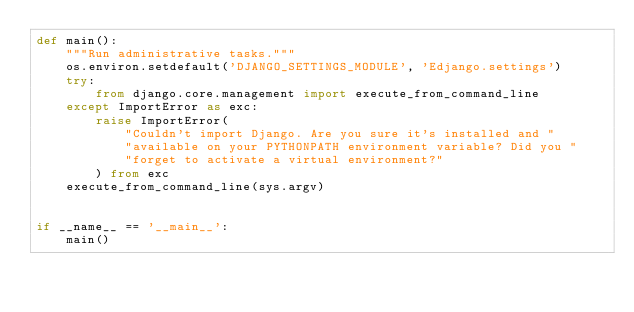<code> <loc_0><loc_0><loc_500><loc_500><_Python_>def main():
    """Run administrative tasks."""
    os.environ.setdefault('DJANGO_SETTINGS_MODULE', 'Edjango.settings')
    try:
        from django.core.management import execute_from_command_line
    except ImportError as exc:
        raise ImportError(
            "Couldn't import Django. Are you sure it's installed and "
            "available on your PYTHONPATH environment variable? Did you "
            "forget to activate a virtual environment?"
        ) from exc
    execute_from_command_line(sys.argv)


if __name__ == '__main__':
    main()
</code> 